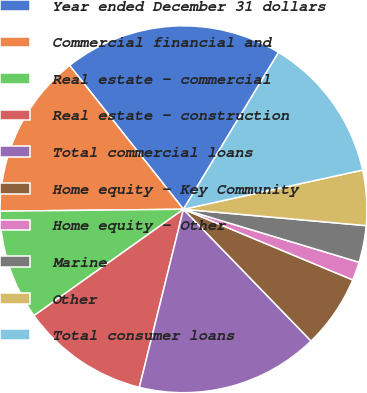Convert chart. <chart><loc_0><loc_0><loc_500><loc_500><pie_chart><fcel>Year ended December 31 dollars<fcel>Commercial financial and<fcel>Real estate - commercial<fcel>Real estate - construction<fcel>Total commercial loans<fcel>Home equity - Key Community<fcel>Home equity - Other<fcel>Marine<fcel>Other<fcel>Total consumer loans<nl><fcel>19.33%<fcel>14.51%<fcel>9.68%<fcel>11.29%<fcel>16.11%<fcel>6.46%<fcel>1.63%<fcel>3.24%<fcel>4.85%<fcel>12.9%<nl></chart> 